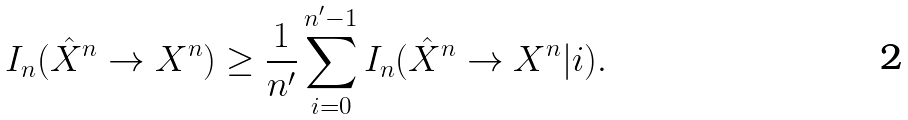<formula> <loc_0><loc_0><loc_500><loc_500>I _ { n } ( \hat { X } ^ { n } \rightarrow X ^ { n } ) \geq \frac { 1 } { n ^ { \prime } } \sum _ { i = 0 } ^ { n ^ { \prime } - 1 } I _ { n } ( \hat { X } ^ { n } \rightarrow X ^ { n } | i ) .</formula> 